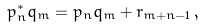Convert formula to latex. <formula><loc_0><loc_0><loc_500><loc_500>p _ { n } ^ { * } q _ { m } = p _ { n } q _ { m } + r _ { m + n - 1 } \, ,</formula> 